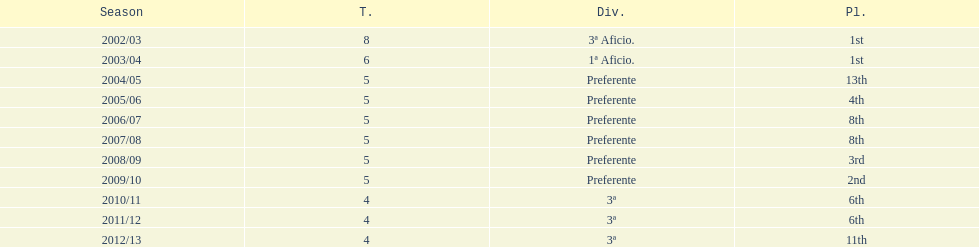How long has internacional de madrid cf been playing in the 3ª division? 3. 